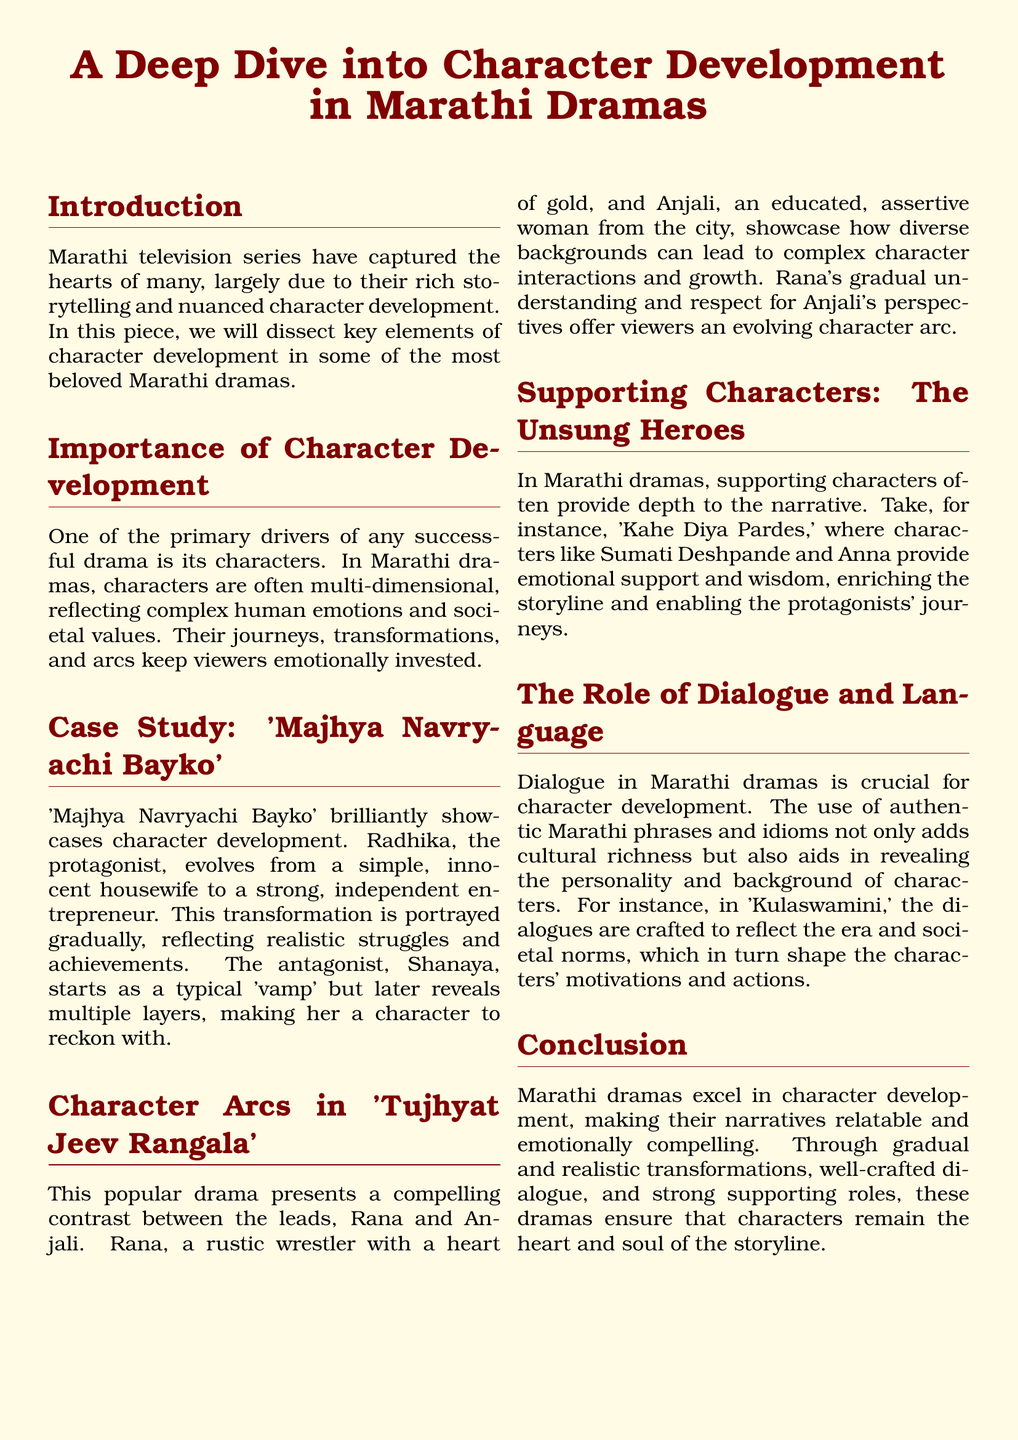What is the title of the document? The title indicates the subject matter of the document, which is focused on character development in Marathi dramas.
Answer: A Deep Dive into Character Development in Marathi Dramas Which character evolves into a strong, independent entrepreneur in 'Majhya Navryachi Bayko'? The document specifies that Radhika is the character who undergoes this transformation.
Answer: Radhika What contrasting backgrounds do the leads in 'Tujhyat Jeev Rangala' come from? The leads, Rana and Anjali, represent different societal backgrounds, influencing their character interactions.
Answer: Rustic and educated Which supporting characters are mentioned in 'Kahe Diya Pardes'? The document highlights Sumati Deshpande and Anna as important supporting characters.
Answer: Sumati Deshpande and Anna How is dialogue significant in Marathi dramas? The document explains that dialogue is crucial for character development, revealing personality and background.
Answer: Cultural richness What type of character arc does Rana experience in 'Tujhyat Jeev Rangala'? The document describes Rana’s character arc as one of gradually understanding and respecting Anjali's perspectives.
Answer: Evolving character arc What is the primary driver of successful Marathi dramas? The document states that characters are the main factor contributing to the success of these dramas.
Answer: Characters What is the primary theme of the document discussed in the conclusion? The conclusion summarizes the richness of character development as a compelling aspect of Marathi dramas.
Answer: Character development 